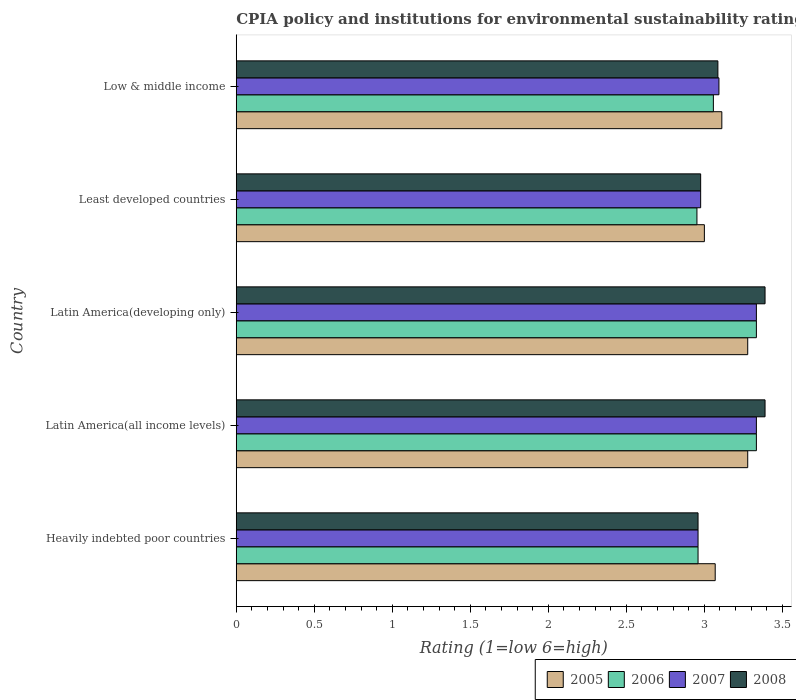How many different coloured bars are there?
Offer a terse response. 4. How many groups of bars are there?
Provide a short and direct response. 5. What is the label of the 5th group of bars from the top?
Your response must be concise. Heavily indebted poor countries. What is the CPIA rating in 2008 in Low & middle income?
Offer a very short reply. 3.09. Across all countries, what is the maximum CPIA rating in 2008?
Provide a succinct answer. 3.39. Across all countries, what is the minimum CPIA rating in 2007?
Your answer should be very brief. 2.96. In which country was the CPIA rating in 2007 maximum?
Offer a very short reply. Latin America(all income levels). In which country was the CPIA rating in 2007 minimum?
Make the answer very short. Heavily indebted poor countries. What is the total CPIA rating in 2008 in the graph?
Ensure brevity in your answer.  15.8. What is the difference between the CPIA rating in 2008 in Heavily indebted poor countries and that in Latin America(all income levels)?
Provide a short and direct response. -0.43. What is the difference between the CPIA rating in 2007 in Latin America(all income levels) and the CPIA rating in 2006 in Least developed countries?
Offer a terse response. 0.38. What is the average CPIA rating in 2006 per country?
Provide a succinct answer. 3.13. What is the difference between the CPIA rating in 2008 and CPIA rating in 2007 in Latin America(all income levels)?
Keep it short and to the point. 0.06. In how many countries, is the CPIA rating in 2008 greater than 3 ?
Provide a short and direct response. 3. What is the ratio of the CPIA rating in 2005 in Heavily indebted poor countries to that in Latin America(all income levels)?
Offer a very short reply. 0.94. Is the CPIA rating in 2008 in Latin America(all income levels) less than that in Latin America(developing only)?
Your response must be concise. No. Is the difference between the CPIA rating in 2008 in Latin America(all income levels) and Least developed countries greater than the difference between the CPIA rating in 2007 in Latin America(all income levels) and Least developed countries?
Your response must be concise. Yes. What is the difference between the highest and the lowest CPIA rating in 2005?
Your answer should be compact. 0.28. Is it the case that in every country, the sum of the CPIA rating in 2008 and CPIA rating in 2006 is greater than the sum of CPIA rating in 2007 and CPIA rating in 2005?
Your answer should be very brief. No. What does the 1st bar from the top in Least developed countries represents?
Provide a succinct answer. 2008. What does the 3rd bar from the bottom in Heavily indebted poor countries represents?
Make the answer very short. 2007. Is it the case that in every country, the sum of the CPIA rating in 2006 and CPIA rating in 2008 is greater than the CPIA rating in 2007?
Provide a succinct answer. Yes. How many bars are there?
Your answer should be compact. 20. Are the values on the major ticks of X-axis written in scientific E-notation?
Your answer should be compact. No. Does the graph contain any zero values?
Your answer should be compact. No. Does the graph contain grids?
Your answer should be very brief. No. Where does the legend appear in the graph?
Offer a very short reply. Bottom right. How many legend labels are there?
Keep it short and to the point. 4. What is the title of the graph?
Make the answer very short. CPIA policy and institutions for environmental sustainability rating. Does "1962" appear as one of the legend labels in the graph?
Offer a very short reply. No. What is the label or title of the Y-axis?
Give a very brief answer. Country. What is the Rating (1=low 6=high) in 2005 in Heavily indebted poor countries?
Provide a short and direct response. 3.07. What is the Rating (1=low 6=high) of 2006 in Heavily indebted poor countries?
Give a very brief answer. 2.96. What is the Rating (1=low 6=high) in 2007 in Heavily indebted poor countries?
Keep it short and to the point. 2.96. What is the Rating (1=low 6=high) in 2008 in Heavily indebted poor countries?
Provide a succinct answer. 2.96. What is the Rating (1=low 6=high) in 2005 in Latin America(all income levels)?
Keep it short and to the point. 3.28. What is the Rating (1=low 6=high) of 2006 in Latin America(all income levels)?
Provide a succinct answer. 3.33. What is the Rating (1=low 6=high) of 2007 in Latin America(all income levels)?
Provide a succinct answer. 3.33. What is the Rating (1=low 6=high) in 2008 in Latin America(all income levels)?
Your answer should be compact. 3.39. What is the Rating (1=low 6=high) in 2005 in Latin America(developing only)?
Ensure brevity in your answer.  3.28. What is the Rating (1=low 6=high) of 2006 in Latin America(developing only)?
Keep it short and to the point. 3.33. What is the Rating (1=low 6=high) in 2007 in Latin America(developing only)?
Offer a terse response. 3.33. What is the Rating (1=low 6=high) in 2008 in Latin America(developing only)?
Your answer should be very brief. 3.39. What is the Rating (1=low 6=high) in 2005 in Least developed countries?
Ensure brevity in your answer.  3. What is the Rating (1=low 6=high) in 2006 in Least developed countries?
Make the answer very short. 2.95. What is the Rating (1=low 6=high) of 2007 in Least developed countries?
Provide a short and direct response. 2.98. What is the Rating (1=low 6=high) in 2008 in Least developed countries?
Make the answer very short. 2.98. What is the Rating (1=low 6=high) of 2005 in Low & middle income?
Provide a succinct answer. 3.11. What is the Rating (1=low 6=high) of 2006 in Low & middle income?
Give a very brief answer. 3.06. What is the Rating (1=low 6=high) of 2007 in Low & middle income?
Your answer should be compact. 3.09. What is the Rating (1=low 6=high) in 2008 in Low & middle income?
Make the answer very short. 3.09. Across all countries, what is the maximum Rating (1=low 6=high) of 2005?
Make the answer very short. 3.28. Across all countries, what is the maximum Rating (1=low 6=high) of 2006?
Keep it short and to the point. 3.33. Across all countries, what is the maximum Rating (1=low 6=high) of 2007?
Your answer should be compact. 3.33. Across all countries, what is the maximum Rating (1=low 6=high) of 2008?
Keep it short and to the point. 3.39. Across all countries, what is the minimum Rating (1=low 6=high) in 2006?
Provide a short and direct response. 2.95. Across all countries, what is the minimum Rating (1=low 6=high) of 2007?
Give a very brief answer. 2.96. Across all countries, what is the minimum Rating (1=low 6=high) in 2008?
Offer a terse response. 2.96. What is the total Rating (1=low 6=high) of 2005 in the graph?
Offer a terse response. 15.74. What is the total Rating (1=low 6=high) in 2006 in the graph?
Your answer should be compact. 15.64. What is the total Rating (1=low 6=high) in 2007 in the graph?
Your answer should be compact. 15.7. What is the total Rating (1=low 6=high) of 2008 in the graph?
Provide a succinct answer. 15.8. What is the difference between the Rating (1=low 6=high) of 2005 in Heavily indebted poor countries and that in Latin America(all income levels)?
Your response must be concise. -0.21. What is the difference between the Rating (1=low 6=high) in 2006 in Heavily indebted poor countries and that in Latin America(all income levels)?
Your answer should be compact. -0.37. What is the difference between the Rating (1=low 6=high) of 2007 in Heavily indebted poor countries and that in Latin America(all income levels)?
Make the answer very short. -0.37. What is the difference between the Rating (1=low 6=high) in 2008 in Heavily indebted poor countries and that in Latin America(all income levels)?
Your answer should be compact. -0.43. What is the difference between the Rating (1=low 6=high) of 2005 in Heavily indebted poor countries and that in Latin America(developing only)?
Keep it short and to the point. -0.21. What is the difference between the Rating (1=low 6=high) in 2006 in Heavily indebted poor countries and that in Latin America(developing only)?
Make the answer very short. -0.37. What is the difference between the Rating (1=low 6=high) in 2007 in Heavily indebted poor countries and that in Latin America(developing only)?
Your answer should be compact. -0.37. What is the difference between the Rating (1=low 6=high) in 2008 in Heavily indebted poor countries and that in Latin America(developing only)?
Ensure brevity in your answer.  -0.43. What is the difference between the Rating (1=low 6=high) of 2005 in Heavily indebted poor countries and that in Least developed countries?
Provide a succinct answer. 0.07. What is the difference between the Rating (1=low 6=high) in 2006 in Heavily indebted poor countries and that in Least developed countries?
Your answer should be very brief. 0.01. What is the difference between the Rating (1=low 6=high) of 2007 in Heavily indebted poor countries and that in Least developed countries?
Offer a very short reply. -0.02. What is the difference between the Rating (1=low 6=high) in 2008 in Heavily indebted poor countries and that in Least developed countries?
Make the answer very short. -0.02. What is the difference between the Rating (1=low 6=high) in 2005 in Heavily indebted poor countries and that in Low & middle income?
Ensure brevity in your answer.  -0.04. What is the difference between the Rating (1=low 6=high) in 2006 in Heavily indebted poor countries and that in Low & middle income?
Provide a short and direct response. -0.1. What is the difference between the Rating (1=low 6=high) of 2007 in Heavily indebted poor countries and that in Low & middle income?
Provide a short and direct response. -0.13. What is the difference between the Rating (1=low 6=high) of 2008 in Heavily indebted poor countries and that in Low & middle income?
Your answer should be very brief. -0.13. What is the difference between the Rating (1=low 6=high) in 2008 in Latin America(all income levels) and that in Latin America(developing only)?
Your answer should be compact. 0. What is the difference between the Rating (1=low 6=high) of 2005 in Latin America(all income levels) and that in Least developed countries?
Give a very brief answer. 0.28. What is the difference between the Rating (1=low 6=high) of 2006 in Latin America(all income levels) and that in Least developed countries?
Your answer should be compact. 0.38. What is the difference between the Rating (1=low 6=high) in 2007 in Latin America(all income levels) and that in Least developed countries?
Make the answer very short. 0.36. What is the difference between the Rating (1=low 6=high) of 2008 in Latin America(all income levels) and that in Least developed countries?
Make the answer very short. 0.41. What is the difference between the Rating (1=low 6=high) of 2005 in Latin America(all income levels) and that in Low & middle income?
Offer a terse response. 0.17. What is the difference between the Rating (1=low 6=high) in 2006 in Latin America(all income levels) and that in Low & middle income?
Your answer should be very brief. 0.28. What is the difference between the Rating (1=low 6=high) in 2007 in Latin America(all income levels) and that in Low & middle income?
Your answer should be very brief. 0.24. What is the difference between the Rating (1=low 6=high) of 2008 in Latin America(all income levels) and that in Low & middle income?
Make the answer very short. 0.3. What is the difference between the Rating (1=low 6=high) of 2005 in Latin America(developing only) and that in Least developed countries?
Give a very brief answer. 0.28. What is the difference between the Rating (1=low 6=high) in 2006 in Latin America(developing only) and that in Least developed countries?
Offer a terse response. 0.38. What is the difference between the Rating (1=low 6=high) in 2007 in Latin America(developing only) and that in Least developed countries?
Ensure brevity in your answer.  0.36. What is the difference between the Rating (1=low 6=high) in 2008 in Latin America(developing only) and that in Least developed countries?
Ensure brevity in your answer.  0.41. What is the difference between the Rating (1=low 6=high) in 2005 in Latin America(developing only) and that in Low & middle income?
Your answer should be compact. 0.17. What is the difference between the Rating (1=low 6=high) in 2006 in Latin America(developing only) and that in Low & middle income?
Your response must be concise. 0.28. What is the difference between the Rating (1=low 6=high) of 2007 in Latin America(developing only) and that in Low & middle income?
Offer a very short reply. 0.24. What is the difference between the Rating (1=low 6=high) of 2008 in Latin America(developing only) and that in Low & middle income?
Provide a short and direct response. 0.3. What is the difference between the Rating (1=low 6=high) of 2005 in Least developed countries and that in Low & middle income?
Your answer should be compact. -0.11. What is the difference between the Rating (1=low 6=high) in 2006 in Least developed countries and that in Low & middle income?
Provide a short and direct response. -0.11. What is the difference between the Rating (1=low 6=high) of 2007 in Least developed countries and that in Low & middle income?
Keep it short and to the point. -0.12. What is the difference between the Rating (1=low 6=high) of 2008 in Least developed countries and that in Low & middle income?
Ensure brevity in your answer.  -0.11. What is the difference between the Rating (1=low 6=high) of 2005 in Heavily indebted poor countries and the Rating (1=low 6=high) of 2006 in Latin America(all income levels)?
Offer a very short reply. -0.26. What is the difference between the Rating (1=low 6=high) in 2005 in Heavily indebted poor countries and the Rating (1=low 6=high) in 2007 in Latin America(all income levels)?
Provide a short and direct response. -0.26. What is the difference between the Rating (1=low 6=high) in 2005 in Heavily indebted poor countries and the Rating (1=low 6=high) in 2008 in Latin America(all income levels)?
Provide a succinct answer. -0.32. What is the difference between the Rating (1=low 6=high) in 2006 in Heavily indebted poor countries and the Rating (1=low 6=high) in 2007 in Latin America(all income levels)?
Ensure brevity in your answer.  -0.37. What is the difference between the Rating (1=low 6=high) in 2006 in Heavily indebted poor countries and the Rating (1=low 6=high) in 2008 in Latin America(all income levels)?
Ensure brevity in your answer.  -0.43. What is the difference between the Rating (1=low 6=high) in 2007 in Heavily indebted poor countries and the Rating (1=low 6=high) in 2008 in Latin America(all income levels)?
Offer a very short reply. -0.43. What is the difference between the Rating (1=low 6=high) of 2005 in Heavily indebted poor countries and the Rating (1=low 6=high) of 2006 in Latin America(developing only)?
Your answer should be very brief. -0.26. What is the difference between the Rating (1=low 6=high) in 2005 in Heavily indebted poor countries and the Rating (1=low 6=high) in 2007 in Latin America(developing only)?
Your answer should be very brief. -0.26. What is the difference between the Rating (1=low 6=high) of 2005 in Heavily indebted poor countries and the Rating (1=low 6=high) of 2008 in Latin America(developing only)?
Your answer should be compact. -0.32. What is the difference between the Rating (1=low 6=high) in 2006 in Heavily indebted poor countries and the Rating (1=low 6=high) in 2007 in Latin America(developing only)?
Your response must be concise. -0.37. What is the difference between the Rating (1=low 6=high) of 2006 in Heavily indebted poor countries and the Rating (1=low 6=high) of 2008 in Latin America(developing only)?
Provide a short and direct response. -0.43. What is the difference between the Rating (1=low 6=high) in 2007 in Heavily indebted poor countries and the Rating (1=low 6=high) in 2008 in Latin America(developing only)?
Give a very brief answer. -0.43. What is the difference between the Rating (1=low 6=high) in 2005 in Heavily indebted poor countries and the Rating (1=low 6=high) in 2006 in Least developed countries?
Give a very brief answer. 0.12. What is the difference between the Rating (1=low 6=high) in 2005 in Heavily indebted poor countries and the Rating (1=low 6=high) in 2007 in Least developed countries?
Ensure brevity in your answer.  0.09. What is the difference between the Rating (1=low 6=high) in 2005 in Heavily indebted poor countries and the Rating (1=low 6=high) in 2008 in Least developed countries?
Ensure brevity in your answer.  0.09. What is the difference between the Rating (1=low 6=high) of 2006 in Heavily indebted poor countries and the Rating (1=low 6=high) of 2007 in Least developed countries?
Provide a succinct answer. -0.02. What is the difference between the Rating (1=low 6=high) of 2006 in Heavily indebted poor countries and the Rating (1=low 6=high) of 2008 in Least developed countries?
Keep it short and to the point. -0.02. What is the difference between the Rating (1=low 6=high) of 2007 in Heavily indebted poor countries and the Rating (1=low 6=high) of 2008 in Least developed countries?
Provide a succinct answer. -0.02. What is the difference between the Rating (1=low 6=high) in 2005 in Heavily indebted poor countries and the Rating (1=low 6=high) in 2006 in Low & middle income?
Provide a short and direct response. 0.01. What is the difference between the Rating (1=low 6=high) in 2005 in Heavily indebted poor countries and the Rating (1=low 6=high) in 2007 in Low & middle income?
Your response must be concise. -0.02. What is the difference between the Rating (1=low 6=high) in 2005 in Heavily indebted poor countries and the Rating (1=low 6=high) in 2008 in Low & middle income?
Your answer should be very brief. -0.02. What is the difference between the Rating (1=low 6=high) of 2006 in Heavily indebted poor countries and the Rating (1=low 6=high) of 2007 in Low & middle income?
Ensure brevity in your answer.  -0.13. What is the difference between the Rating (1=low 6=high) of 2006 in Heavily indebted poor countries and the Rating (1=low 6=high) of 2008 in Low & middle income?
Make the answer very short. -0.13. What is the difference between the Rating (1=low 6=high) in 2007 in Heavily indebted poor countries and the Rating (1=low 6=high) in 2008 in Low & middle income?
Offer a terse response. -0.13. What is the difference between the Rating (1=low 6=high) in 2005 in Latin America(all income levels) and the Rating (1=low 6=high) in 2006 in Latin America(developing only)?
Offer a terse response. -0.06. What is the difference between the Rating (1=low 6=high) of 2005 in Latin America(all income levels) and the Rating (1=low 6=high) of 2007 in Latin America(developing only)?
Your response must be concise. -0.06. What is the difference between the Rating (1=low 6=high) of 2005 in Latin America(all income levels) and the Rating (1=low 6=high) of 2008 in Latin America(developing only)?
Offer a terse response. -0.11. What is the difference between the Rating (1=low 6=high) of 2006 in Latin America(all income levels) and the Rating (1=low 6=high) of 2007 in Latin America(developing only)?
Your response must be concise. 0. What is the difference between the Rating (1=low 6=high) in 2006 in Latin America(all income levels) and the Rating (1=low 6=high) in 2008 in Latin America(developing only)?
Provide a short and direct response. -0.06. What is the difference between the Rating (1=low 6=high) in 2007 in Latin America(all income levels) and the Rating (1=low 6=high) in 2008 in Latin America(developing only)?
Keep it short and to the point. -0.06. What is the difference between the Rating (1=low 6=high) of 2005 in Latin America(all income levels) and the Rating (1=low 6=high) of 2006 in Least developed countries?
Your response must be concise. 0.33. What is the difference between the Rating (1=low 6=high) in 2005 in Latin America(all income levels) and the Rating (1=low 6=high) in 2007 in Least developed countries?
Provide a succinct answer. 0.3. What is the difference between the Rating (1=low 6=high) in 2005 in Latin America(all income levels) and the Rating (1=low 6=high) in 2008 in Least developed countries?
Give a very brief answer. 0.3. What is the difference between the Rating (1=low 6=high) of 2006 in Latin America(all income levels) and the Rating (1=low 6=high) of 2007 in Least developed countries?
Ensure brevity in your answer.  0.36. What is the difference between the Rating (1=low 6=high) in 2006 in Latin America(all income levels) and the Rating (1=low 6=high) in 2008 in Least developed countries?
Make the answer very short. 0.36. What is the difference between the Rating (1=low 6=high) in 2007 in Latin America(all income levels) and the Rating (1=low 6=high) in 2008 in Least developed countries?
Your answer should be compact. 0.36. What is the difference between the Rating (1=low 6=high) of 2005 in Latin America(all income levels) and the Rating (1=low 6=high) of 2006 in Low & middle income?
Offer a very short reply. 0.22. What is the difference between the Rating (1=low 6=high) in 2005 in Latin America(all income levels) and the Rating (1=low 6=high) in 2007 in Low & middle income?
Keep it short and to the point. 0.18. What is the difference between the Rating (1=low 6=high) of 2005 in Latin America(all income levels) and the Rating (1=low 6=high) of 2008 in Low & middle income?
Provide a succinct answer. 0.19. What is the difference between the Rating (1=low 6=high) in 2006 in Latin America(all income levels) and the Rating (1=low 6=high) in 2007 in Low & middle income?
Make the answer very short. 0.24. What is the difference between the Rating (1=low 6=high) in 2006 in Latin America(all income levels) and the Rating (1=low 6=high) in 2008 in Low & middle income?
Offer a very short reply. 0.25. What is the difference between the Rating (1=low 6=high) of 2007 in Latin America(all income levels) and the Rating (1=low 6=high) of 2008 in Low & middle income?
Your response must be concise. 0.25. What is the difference between the Rating (1=low 6=high) in 2005 in Latin America(developing only) and the Rating (1=low 6=high) in 2006 in Least developed countries?
Give a very brief answer. 0.33. What is the difference between the Rating (1=low 6=high) in 2005 in Latin America(developing only) and the Rating (1=low 6=high) in 2007 in Least developed countries?
Make the answer very short. 0.3. What is the difference between the Rating (1=low 6=high) of 2005 in Latin America(developing only) and the Rating (1=low 6=high) of 2008 in Least developed countries?
Your response must be concise. 0.3. What is the difference between the Rating (1=low 6=high) of 2006 in Latin America(developing only) and the Rating (1=low 6=high) of 2007 in Least developed countries?
Ensure brevity in your answer.  0.36. What is the difference between the Rating (1=low 6=high) of 2006 in Latin America(developing only) and the Rating (1=low 6=high) of 2008 in Least developed countries?
Give a very brief answer. 0.36. What is the difference between the Rating (1=low 6=high) in 2007 in Latin America(developing only) and the Rating (1=low 6=high) in 2008 in Least developed countries?
Offer a very short reply. 0.36. What is the difference between the Rating (1=low 6=high) in 2005 in Latin America(developing only) and the Rating (1=low 6=high) in 2006 in Low & middle income?
Your response must be concise. 0.22. What is the difference between the Rating (1=low 6=high) of 2005 in Latin America(developing only) and the Rating (1=low 6=high) of 2007 in Low & middle income?
Your response must be concise. 0.18. What is the difference between the Rating (1=low 6=high) in 2005 in Latin America(developing only) and the Rating (1=low 6=high) in 2008 in Low & middle income?
Offer a very short reply. 0.19. What is the difference between the Rating (1=low 6=high) of 2006 in Latin America(developing only) and the Rating (1=low 6=high) of 2007 in Low & middle income?
Make the answer very short. 0.24. What is the difference between the Rating (1=low 6=high) of 2006 in Latin America(developing only) and the Rating (1=low 6=high) of 2008 in Low & middle income?
Keep it short and to the point. 0.25. What is the difference between the Rating (1=low 6=high) of 2007 in Latin America(developing only) and the Rating (1=low 6=high) of 2008 in Low & middle income?
Offer a very short reply. 0.25. What is the difference between the Rating (1=low 6=high) in 2005 in Least developed countries and the Rating (1=low 6=high) in 2006 in Low & middle income?
Provide a succinct answer. -0.06. What is the difference between the Rating (1=low 6=high) of 2005 in Least developed countries and the Rating (1=low 6=high) of 2007 in Low & middle income?
Give a very brief answer. -0.09. What is the difference between the Rating (1=low 6=high) of 2005 in Least developed countries and the Rating (1=low 6=high) of 2008 in Low & middle income?
Provide a short and direct response. -0.09. What is the difference between the Rating (1=low 6=high) in 2006 in Least developed countries and the Rating (1=low 6=high) in 2007 in Low & middle income?
Offer a very short reply. -0.14. What is the difference between the Rating (1=low 6=high) in 2006 in Least developed countries and the Rating (1=low 6=high) in 2008 in Low & middle income?
Your answer should be compact. -0.13. What is the difference between the Rating (1=low 6=high) in 2007 in Least developed countries and the Rating (1=low 6=high) in 2008 in Low & middle income?
Offer a terse response. -0.11. What is the average Rating (1=low 6=high) in 2005 per country?
Offer a terse response. 3.15. What is the average Rating (1=low 6=high) in 2006 per country?
Give a very brief answer. 3.13. What is the average Rating (1=low 6=high) of 2007 per country?
Provide a succinct answer. 3.14. What is the average Rating (1=low 6=high) of 2008 per country?
Provide a short and direct response. 3.16. What is the difference between the Rating (1=low 6=high) of 2005 and Rating (1=low 6=high) of 2006 in Heavily indebted poor countries?
Provide a succinct answer. 0.11. What is the difference between the Rating (1=low 6=high) in 2005 and Rating (1=low 6=high) in 2007 in Heavily indebted poor countries?
Your answer should be compact. 0.11. What is the difference between the Rating (1=low 6=high) of 2005 and Rating (1=low 6=high) of 2008 in Heavily indebted poor countries?
Your response must be concise. 0.11. What is the difference between the Rating (1=low 6=high) of 2006 and Rating (1=low 6=high) of 2007 in Heavily indebted poor countries?
Offer a very short reply. 0. What is the difference between the Rating (1=low 6=high) of 2005 and Rating (1=low 6=high) of 2006 in Latin America(all income levels)?
Provide a succinct answer. -0.06. What is the difference between the Rating (1=low 6=high) in 2005 and Rating (1=low 6=high) in 2007 in Latin America(all income levels)?
Offer a terse response. -0.06. What is the difference between the Rating (1=low 6=high) in 2005 and Rating (1=low 6=high) in 2008 in Latin America(all income levels)?
Provide a short and direct response. -0.11. What is the difference between the Rating (1=low 6=high) of 2006 and Rating (1=low 6=high) of 2007 in Latin America(all income levels)?
Provide a short and direct response. 0. What is the difference between the Rating (1=low 6=high) of 2006 and Rating (1=low 6=high) of 2008 in Latin America(all income levels)?
Make the answer very short. -0.06. What is the difference between the Rating (1=low 6=high) of 2007 and Rating (1=low 6=high) of 2008 in Latin America(all income levels)?
Provide a short and direct response. -0.06. What is the difference between the Rating (1=low 6=high) in 2005 and Rating (1=low 6=high) in 2006 in Latin America(developing only)?
Keep it short and to the point. -0.06. What is the difference between the Rating (1=low 6=high) of 2005 and Rating (1=low 6=high) of 2007 in Latin America(developing only)?
Provide a short and direct response. -0.06. What is the difference between the Rating (1=low 6=high) in 2005 and Rating (1=low 6=high) in 2008 in Latin America(developing only)?
Make the answer very short. -0.11. What is the difference between the Rating (1=low 6=high) of 2006 and Rating (1=low 6=high) of 2008 in Latin America(developing only)?
Offer a terse response. -0.06. What is the difference between the Rating (1=low 6=high) of 2007 and Rating (1=low 6=high) of 2008 in Latin America(developing only)?
Provide a succinct answer. -0.06. What is the difference between the Rating (1=low 6=high) of 2005 and Rating (1=low 6=high) of 2006 in Least developed countries?
Provide a succinct answer. 0.05. What is the difference between the Rating (1=low 6=high) in 2005 and Rating (1=low 6=high) in 2007 in Least developed countries?
Offer a very short reply. 0.02. What is the difference between the Rating (1=low 6=high) of 2005 and Rating (1=low 6=high) of 2008 in Least developed countries?
Your response must be concise. 0.02. What is the difference between the Rating (1=low 6=high) of 2006 and Rating (1=low 6=high) of 2007 in Least developed countries?
Make the answer very short. -0.02. What is the difference between the Rating (1=low 6=high) of 2006 and Rating (1=low 6=high) of 2008 in Least developed countries?
Ensure brevity in your answer.  -0.02. What is the difference between the Rating (1=low 6=high) in 2007 and Rating (1=low 6=high) in 2008 in Least developed countries?
Your response must be concise. 0. What is the difference between the Rating (1=low 6=high) in 2005 and Rating (1=low 6=high) in 2006 in Low & middle income?
Offer a terse response. 0.05. What is the difference between the Rating (1=low 6=high) in 2005 and Rating (1=low 6=high) in 2007 in Low & middle income?
Your response must be concise. 0.02. What is the difference between the Rating (1=low 6=high) of 2005 and Rating (1=low 6=high) of 2008 in Low & middle income?
Your answer should be compact. 0.03. What is the difference between the Rating (1=low 6=high) of 2006 and Rating (1=low 6=high) of 2007 in Low & middle income?
Make the answer very short. -0.04. What is the difference between the Rating (1=low 6=high) of 2006 and Rating (1=low 6=high) of 2008 in Low & middle income?
Give a very brief answer. -0.03. What is the difference between the Rating (1=low 6=high) of 2007 and Rating (1=low 6=high) of 2008 in Low & middle income?
Make the answer very short. 0.01. What is the ratio of the Rating (1=low 6=high) of 2005 in Heavily indebted poor countries to that in Latin America(all income levels)?
Provide a short and direct response. 0.94. What is the ratio of the Rating (1=low 6=high) in 2006 in Heavily indebted poor countries to that in Latin America(all income levels)?
Provide a short and direct response. 0.89. What is the ratio of the Rating (1=low 6=high) in 2007 in Heavily indebted poor countries to that in Latin America(all income levels)?
Keep it short and to the point. 0.89. What is the ratio of the Rating (1=low 6=high) in 2008 in Heavily indebted poor countries to that in Latin America(all income levels)?
Make the answer very short. 0.87. What is the ratio of the Rating (1=low 6=high) of 2005 in Heavily indebted poor countries to that in Latin America(developing only)?
Your response must be concise. 0.94. What is the ratio of the Rating (1=low 6=high) of 2006 in Heavily indebted poor countries to that in Latin America(developing only)?
Your answer should be compact. 0.89. What is the ratio of the Rating (1=low 6=high) in 2007 in Heavily indebted poor countries to that in Latin America(developing only)?
Ensure brevity in your answer.  0.89. What is the ratio of the Rating (1=low 6=high) in 2008 in Heavily indebted poor countries to that in Latin America(developing only)?
Your answer should be very brief. 0.87. What is the ratio of the Rating (1=low 6=high) of 2005 in Heavily indebted poor countries to that in Least developed countries?
Keep it short and to the point. 1.02. What is the ratio of the Rating (1=low 6=high) of 2007 in Heavily indebted poor countries to that in Least developed countries?
Keep it short and to the point. 0.99. What is the ratio of the Rating (1=low 6=high) of 2008 in Heavily indebted poor countries to that in Least developed countries?
Give a very brief answer. 0.99. What is the ratio of the Rating (1=low 6=high) of 2005 in Heavily indebted poor countries to that in Low & middle income?
Your answer should be very brief. 0.99. What is the ratio of the Rating (1=low 6=high) in 2006 in Heavily indebted poor countries to that in Low & middle income?
Offer a very short reply. 0.97. What is the ratio of the Rating (1=low 6=high) in 2007 in Heavily indebted poor countries to that in Low & middle income?
Offer a very short reply. 0.96. What is the ratio of the Rating (1=low 6=high) in 2008 in Heavily indebted poor countries to that in Low & middle income?
Give a very brief answer. 0.96. What is the ratio of the Rating (1=low 6=high) in 2005 in Latin America(all income levels) to that in Latin America(developing only)?
Give a very brief answer. 1. What is the ratio of the Rating (1=low 6=high) in 2007 in Latin America(all income levels) to that in Latin America(developing only)?
Provide a short and direct response. 1. What is the ratio of the Rating (1=low 6=high) of 2005 in Latin America(all income levels) to that in Least developed countries?
Ensure brevity in your answer.  1.09. What is the ratio of the Rating (1=low 6=high) in 2006 in Latin America(all income levels) to that in Least developed countries?
Offer a very short reply. 1.13. What is the ratio of the Rating (1=low 6=high) in 2007 in Latin America(all income levels) to that in Least developed countries?
Make the answer very short. 1.12. What is the ratio of the Rating (1=low 6=high) of 2008 in Latin America(all income levels) to that in Least developed countries?
Offer a very short reply. 1.14. What is the ratio of the Rating (1=low 6=high) in 2005 in Latin America(all income levels) to that in Low & middle income?
Your response must be concise. 1.05. What is the ratio of the Rating (1=low 6=high) in 2006 in Latin America(all income levels) to that in Low & middle income?
Make the answer very short. 1.09. What is the ratio of the Rating (1=low 6=high) of 2007 in Latin America(all income levels) to that in Low & middle income?
Offer a terse response. 1.08. What is the ratio of the Rating (1=low 6=high) of 2008 in Latin America(all income levels) to that in Low & middle income?
Ensure brevity in your answer.  1.1. What is the ratio of the Rating (1=low 6=high) of 2005 in Latin America(developing only) to that in Least developed countries?
Your answer should be very brief. 1.09. What is the ratio of the Rating (1=low 6=high) in 2006 in Latin America(developing only) to that in Least developed countries?
Keep it short and to the point. 1.13. What is the ratio of the Rating (1=low 6=high) of 2007 in Latin America(developing only) to that in Least developed countries?
Your answer should be compact. 1.12. What is the ratio of the Rating (1=low 6=high) of 2008 in Latin America(developing only) to that in Least developed countries?
Give a very brief answer. 1.14. What is the ratio of the Rating (1=low 6=high) in 2005 in Latin America(developing only) to that in Low & middle income?
Provide a succinct answer. 1.05. What is the ratio of the Rating (1=low 6=high) in 2006 in Latin America(developing only) to that in Low & middle income?
Your answer should be compact. 1.09. What is the ratio of the Rating (1=low 6=high) in 2007 in Latin America(developing only) to that in Low & middle income?
Provide a short and direct response. 1.08. What is the ratio of the Rating (1=low 6=high) of 2008 in Latin America(developing only) to that in Low & middle income?
Your response must be concise. 1.1. What is the ratio of the Rating (1=low 6=high) of 2005 in Least developed countries to that in Low & middle income?
Your answer should be compact. 0.96. What is the ratio of the Rating (1=low 6=high) in 2006 in Least developed countries to that in Low & middle income?
Offer a terse response. 0.97. What is the ratio of the Rating (1=low 6=high) in 2007 in Least developed countries to that in Low & middle income?
Offer a terse response. 0.96. What is the ratio of the Rating (1=low 6=high) of 2008 in Least developed countries to that in Low & middle income?
Your response must be concise. 0.96. What is the difference between the highest and the lowest Rating (1=low 6=high) in 2005?
Offer a very short reply. 0.28. What is the difference between the highest and the lowest Rating (1=low 6=high) in 2006?
Ensure brevity in your answer.  0.38. What is the difference between the highest and the lowest Rating (1=low 6=high) in 2007?
Ensure brevity in your answer.  0.37. What is the difference between the highest and the lowest Rating (1=low 6=high) in 2008?
Offer a very short reply. 0.43. 